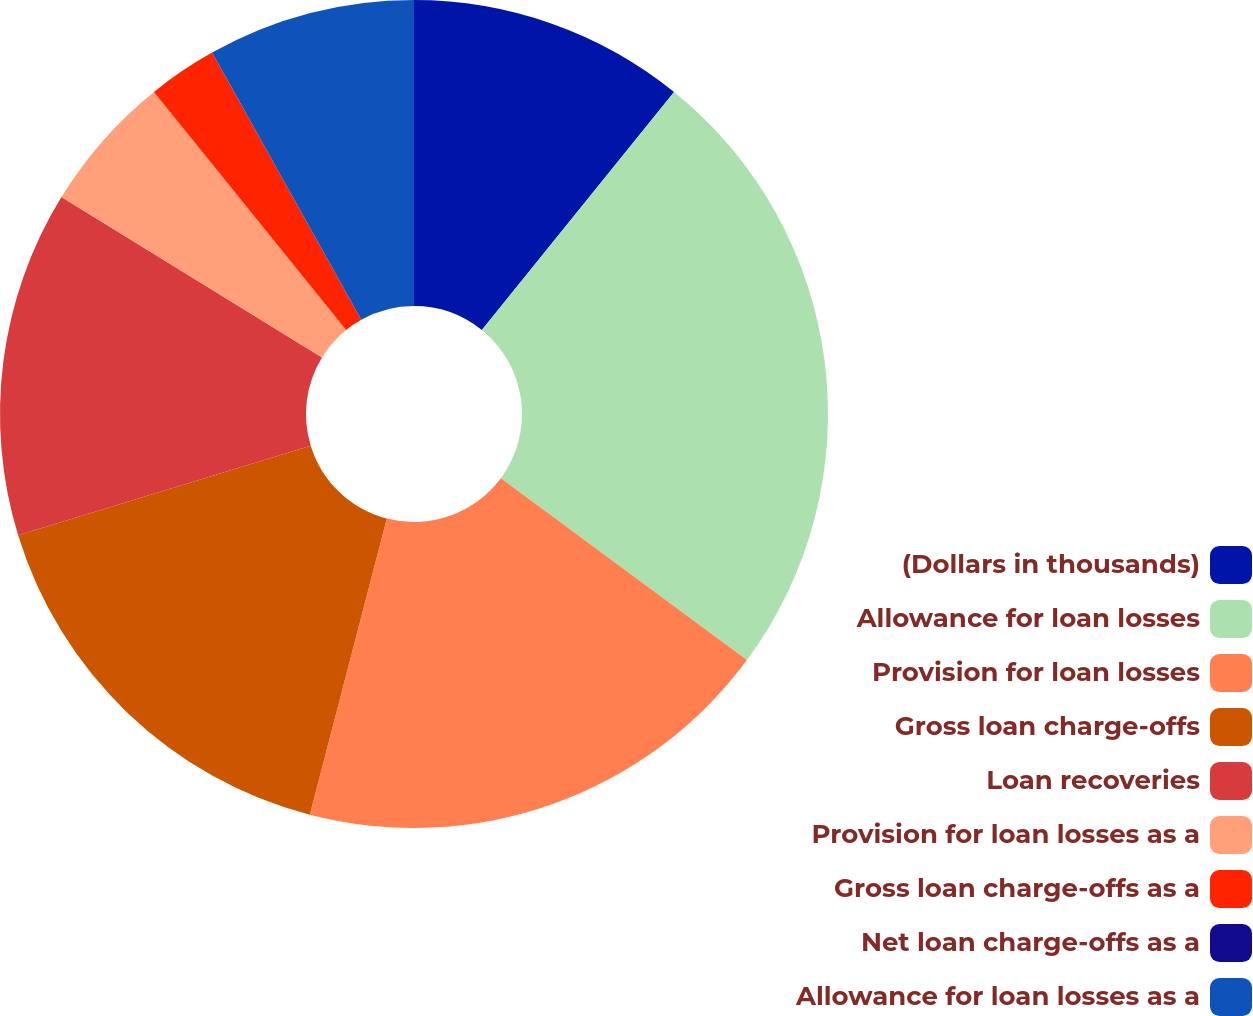<chart> <loc_0><loc_0><loc_500><loc_500><pie_chart><fcel>(Dollars in thousands)<fcel>Allowance for loan losses<fcel>Provision for loan losses<fcel>Gross loan charge-offs<fcel>Loan recoveries<fcel>Provision for loan losses as a<fcel>Gross loan charge-offs as a<fcel>Net loan charge-offs as a<fcel>Allowance for loan losses as a<nl><fcel>10.81%<fcel>24.32%<fcel>18.92%<fcel>16.22%<fcel>13.51%<fcel>5.41%<fcel>2.7%<fcel>0.0%<fcel>8.11%<nl></chart> 